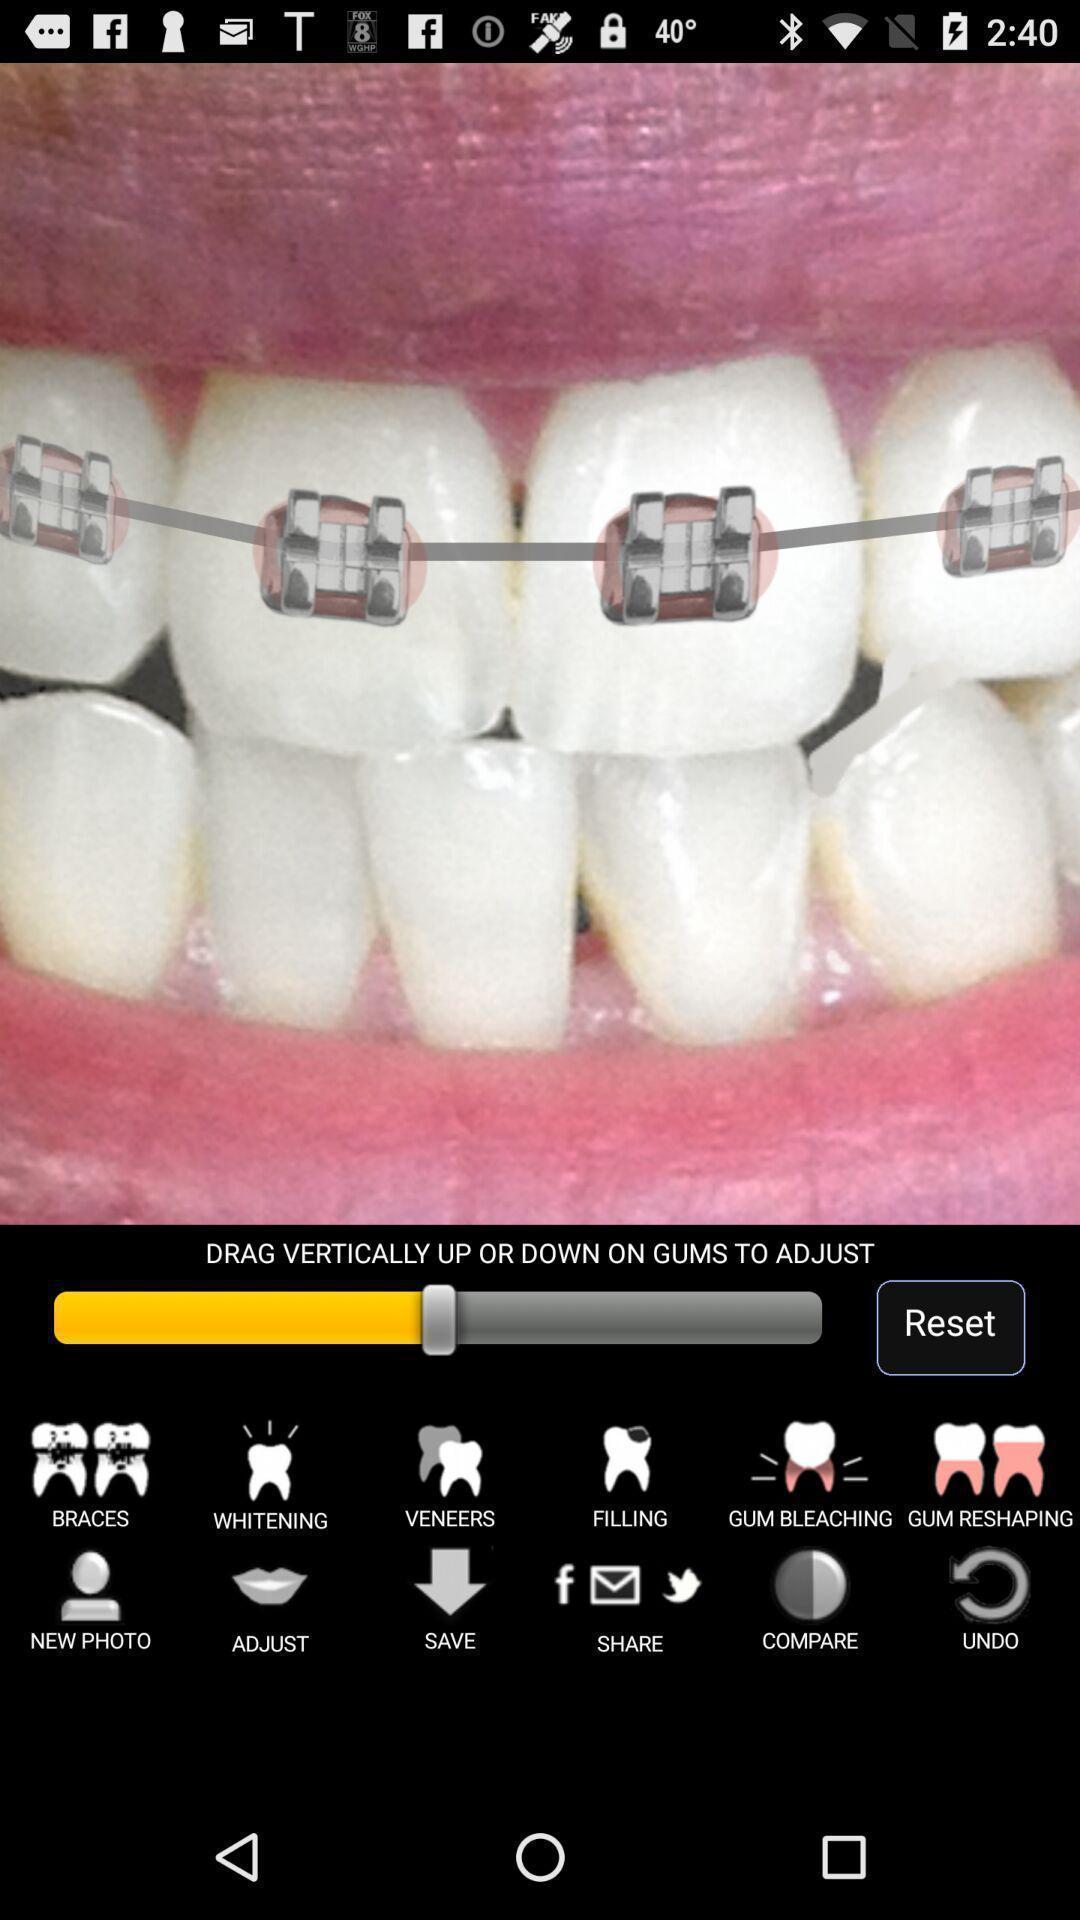Explain the elements present in this screenshot. Photo of a teeth to adjust. 